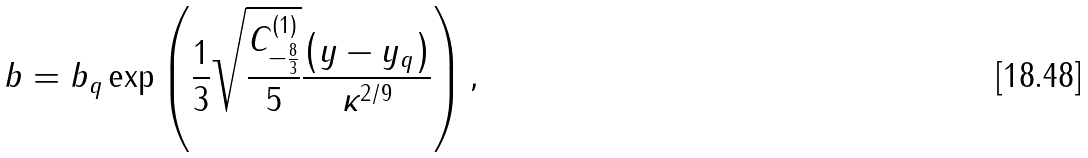<formula> <loc_0><loc_0><loc_500><loc_500>b = b _ { q } \exp \left ( \frac { 1 } { 3 } \sqrt { \frac { C ^ { \left ( 1 \right ) } _ { - \frac { 8 } { 3 } } } { 5 } } \frac { \left ( y - y _ { q } \right ) } { \kappa ^ { 2 / 9 } } \right ) ,</formula> 